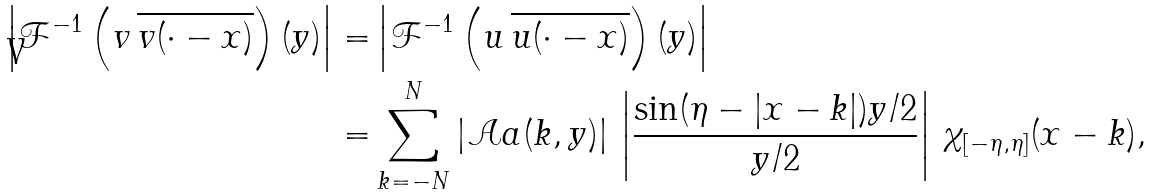Convert formula to latex. <formula><loc_0><loc_0><loc_500><loc_500>\left | \mathcal { F } ^ { - 1 } \left ( v \, \overline { v ( \cdot - x ) } \right ) ( y ) \right | = & \left | \mathcal { F } ^ { - 1 } \left ( u \, \overline { u ( \cdot - x ) } \right ) ( y ) \right | \\ = & \sum _ { k = - N } ^ { N } | \mathcal { A } a ( k , y ) | \, \left | \frac { \sin ( \eta - | x - k | ) y / 2 } { y / 2 } \right | \, \chi _ { [ - \eta , \eta ] } ( x - k ) ,</formula> 